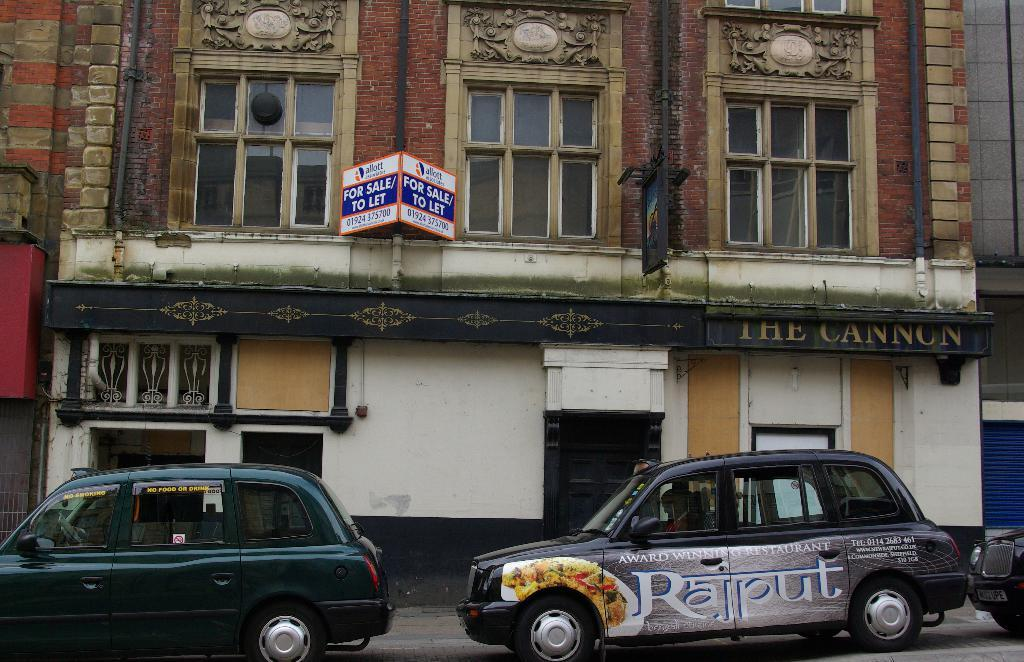What type of structure is in the image? There is a building in the image. What features can be observed on the building? The building has windows and glass elements. Are there any vehicles near the building? Yes, there are cars parked near the building. What is the name of the building? The name of the building is "the cannon." How many boys are riding the amusement park ride in the image? There is no amusement park ride or boys present in the image; it features a building with cars parked nearby. 